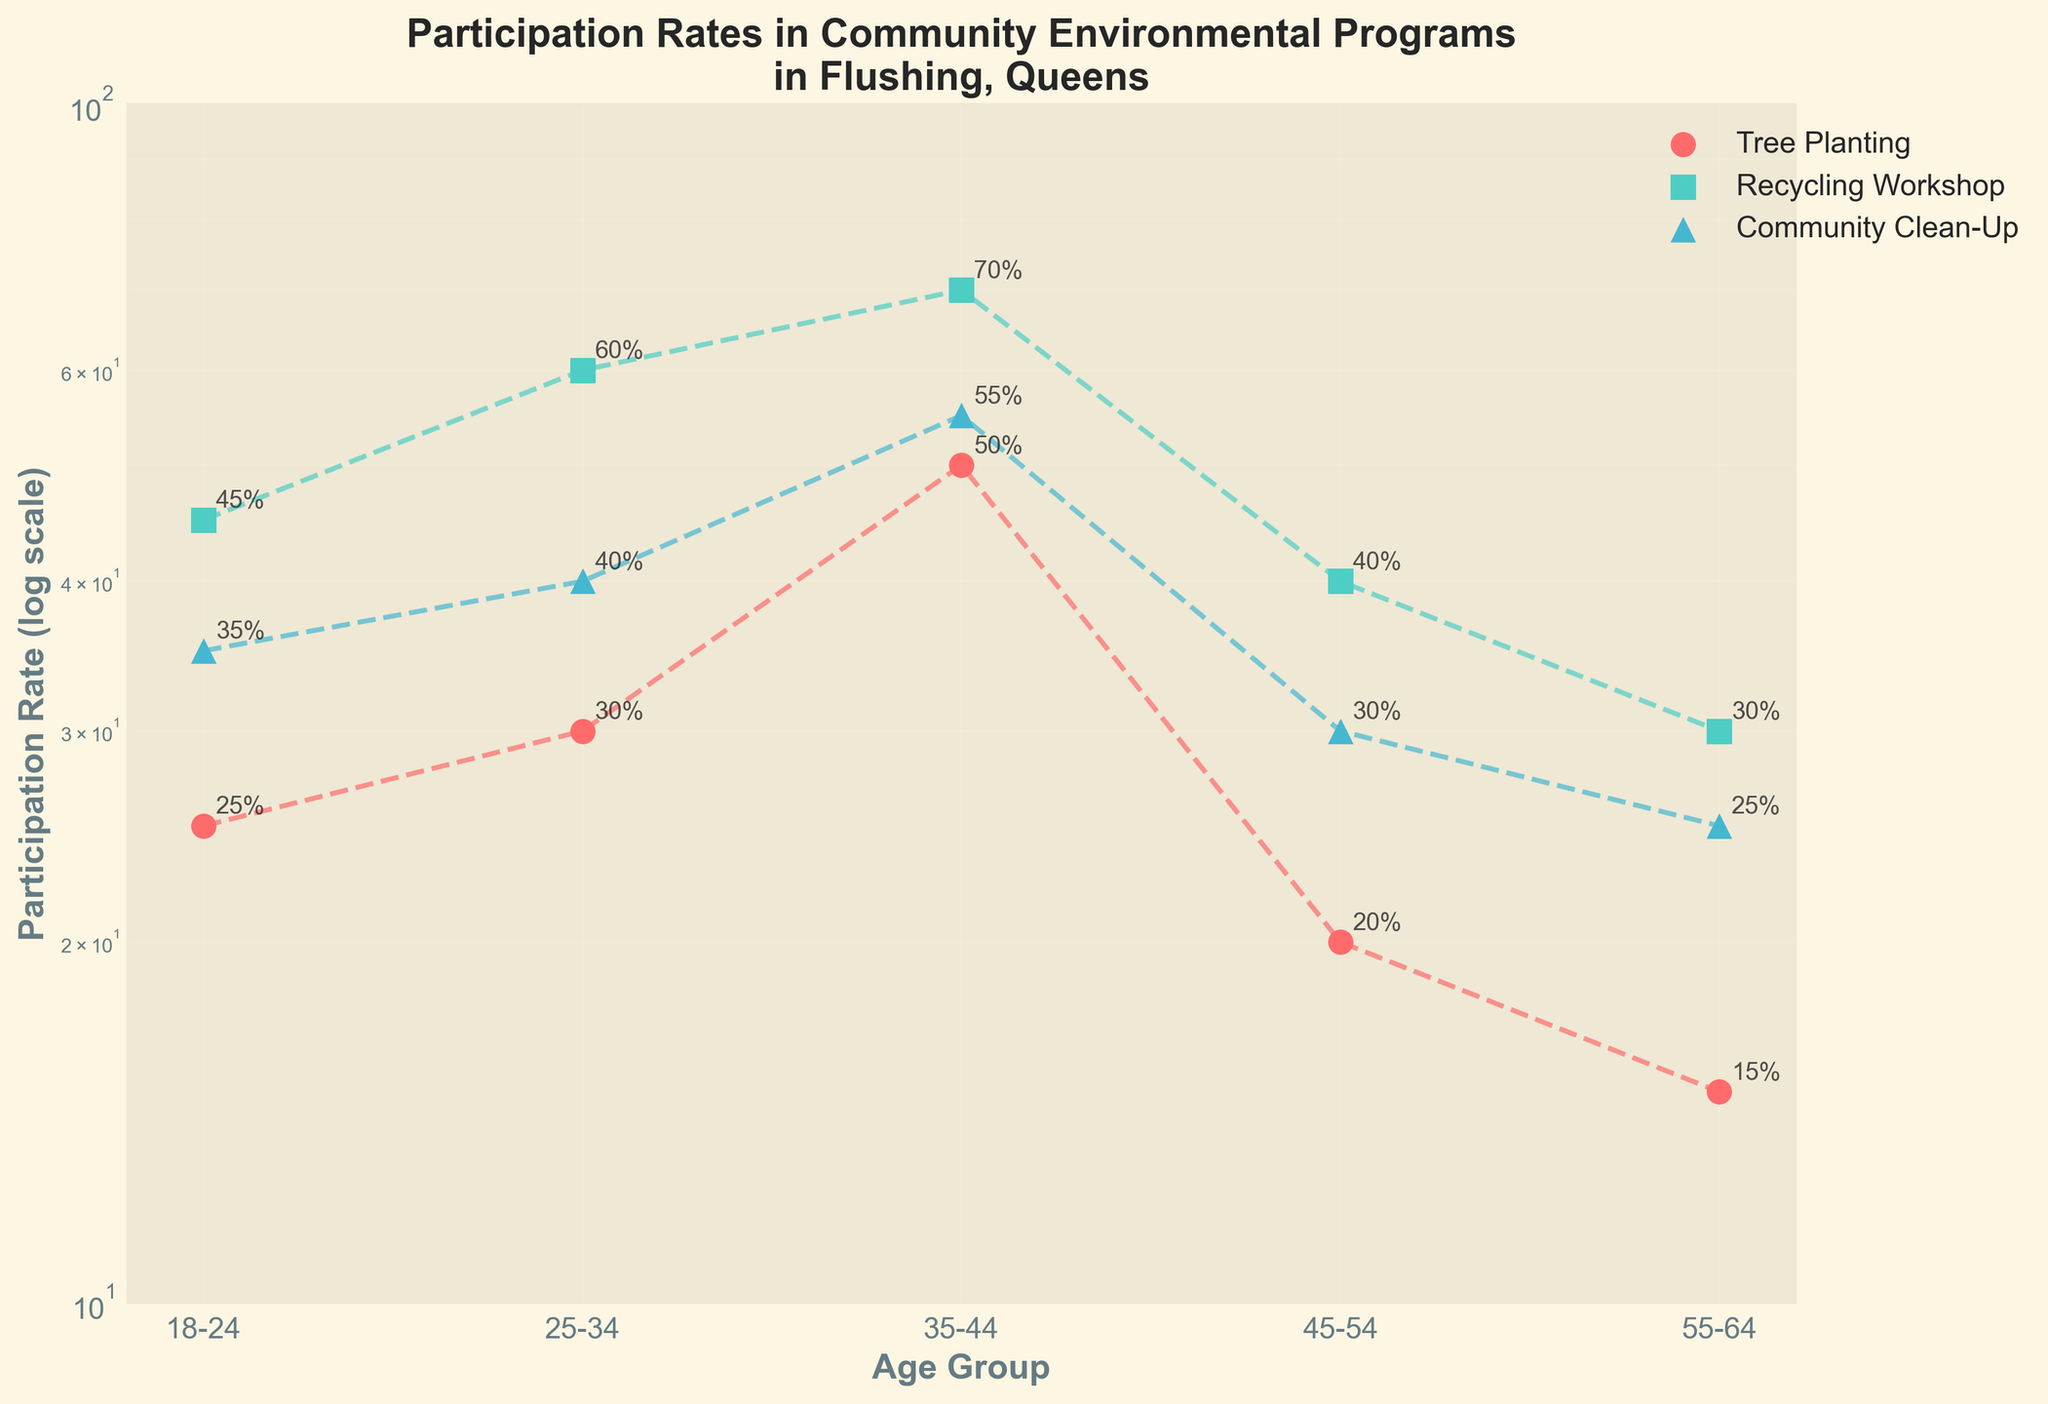What is the title of the figure? The title is usually found at the top of the plot. It summarizes the main theme of the figure, making it easier for viewers to understand what the plot is about at a glance.
Answer: Participation Rates in Community Environmental Programs in Flushing, Queens Which age group has the highest participation rate in Recycling Workshop? To find this, look at the data points for Recycling Workshop across different age groups and identify the highest rate among them.
Answer: 35-44 What is the participation rate for Tree Planting in the 25-34 age group? Locate the data points specifically for Tree Planting and then find the one corresponding to the 25-34 age group.
Answer: 30 How many program types are represented in the plot? The legend or the scatter plot markers/colors can help us identify the number of distinct program types shown in the plot.
Answer: 3 Which age group shows the lowest participation rate for Community Clean-Up? Compare the data points for Community Clean-Up across all age groups to find the lowest value.
Answer: 55-64 What is the average participation rate in Community Clean-Up for all age groups? Calculate the average of the participation rates for Community Clean-Up across all age groups: (35 + 40 + 55 + 30 + 25) / 5.
Answer: 37 Is the participation rate for Tree Planting higher or lower than that for Recycling Workshop in the 45-54 age group? Look at the participation rates for both Tree Planting and Recycling Workshop in the 45-54 age group and compare them.
Answer: Lower What is the range of participation rates for the Recycling Workshop? The range can be found by subtracting the smallest participation rate from the largest participation rate in the Recycling Workshop program type. The rates are (30 to 70), so 70 - 30.
Answer: 40 Are there any age groups where the participation rate for Community Clean-Up is higher than the rate for Tree Planting? If yes, which ones? Compare the Community Clean-Up and Tree Planting rates for each age group and identify the cases where the former is higher than the latter. For example, for the 35-44 age group, 55 > 50.
Answer: 35-44 